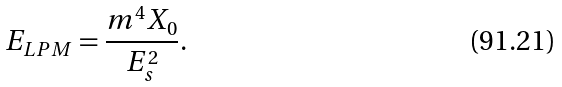Convert formula to latex. <formula><loc_0><loc_0><loc_500><loc_500>E _ { L P M } = \frac { m ^ { 4 } X _ { 0 } } { E _ { s } ^ { 2 } } .</formula> 